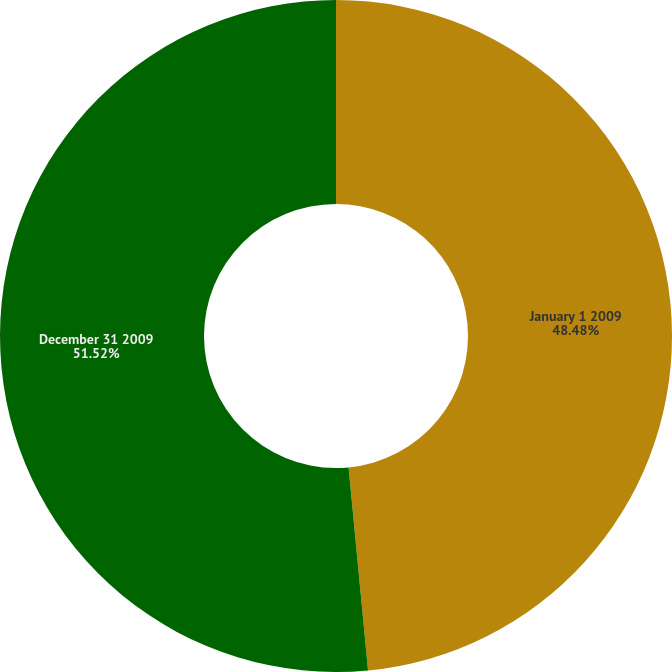Convert chart. <chart><loc_0><loc_0><loc_500><loc_500><pie_chart><fcel>January 1 2009<fcel>December 31 2009<nl><fcel>48.48%<fcel>51.52%<nl></chart> 